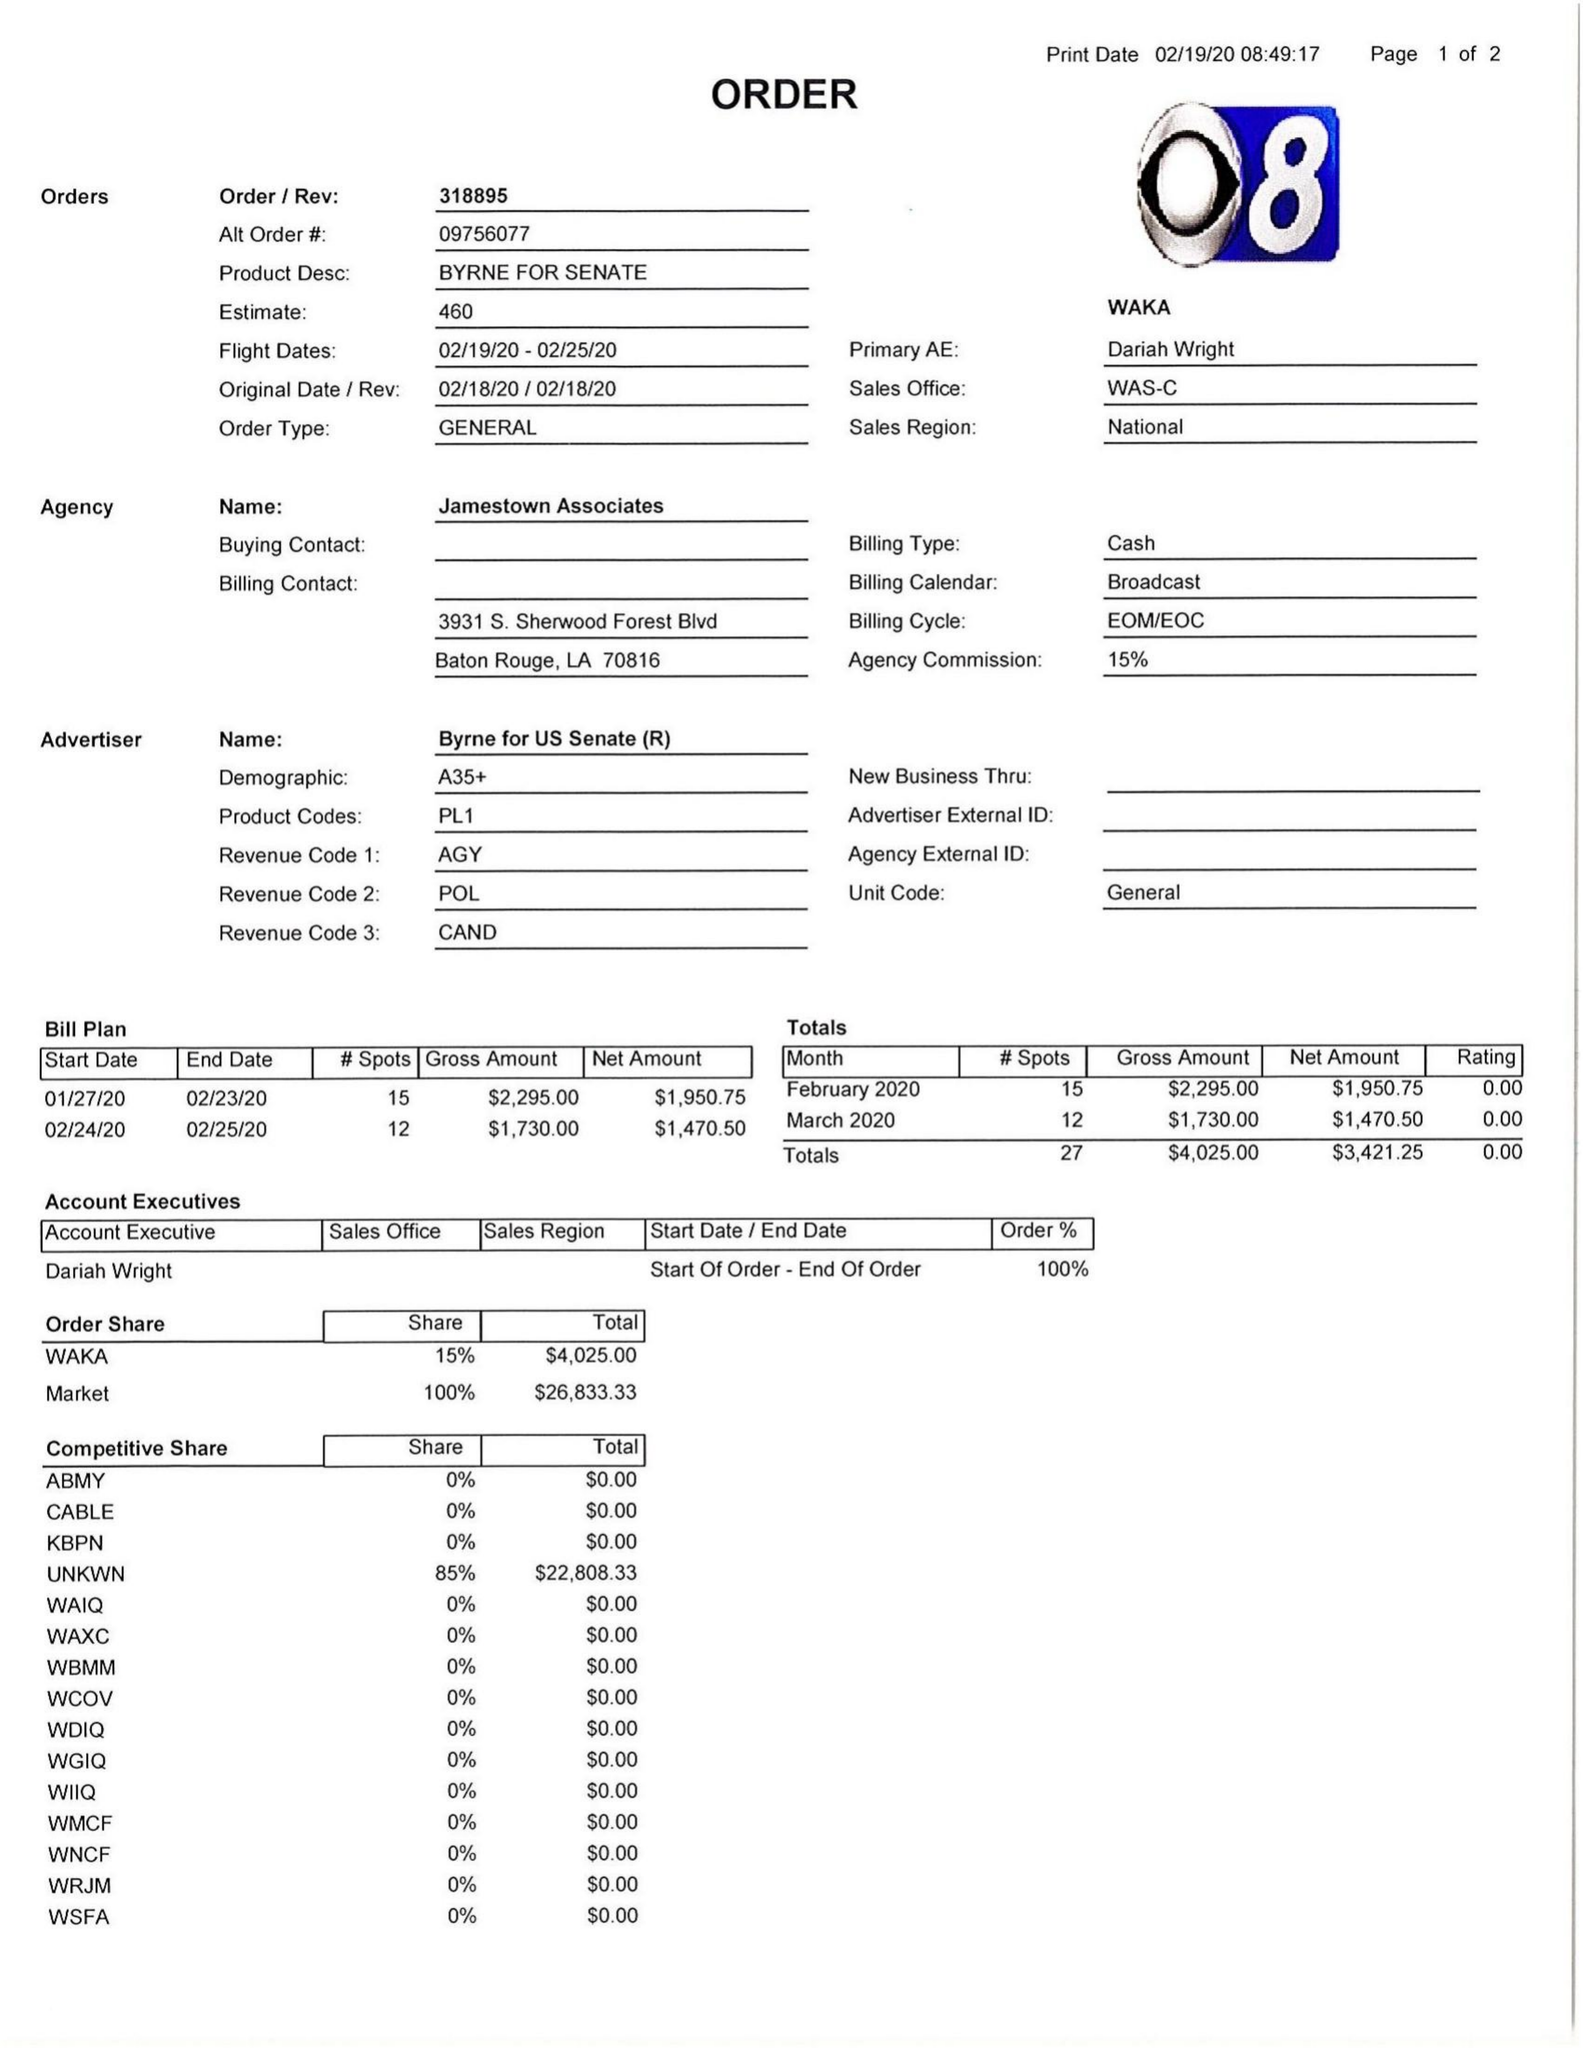What is the value for the flight_to?
Answer the question using a single word or phrase. 02/25/20 